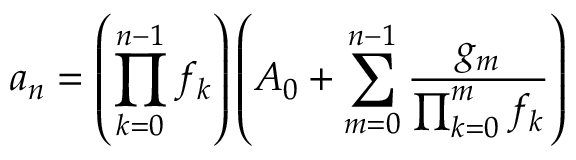<formula> <loc_0><loc_0><loc_500><loc_500>a _ { n } = \left ( \prod _ { k = 0 } ^ { n - 1 } f _ { k } \right ) \left ( A _ { 0 } + \sum _ { m = 0 } ^ { n - 1 } { \frac { g _ { m } } { \prod _ { k = 0 } ^ { m } f _ { k } } } \right )</formula> 